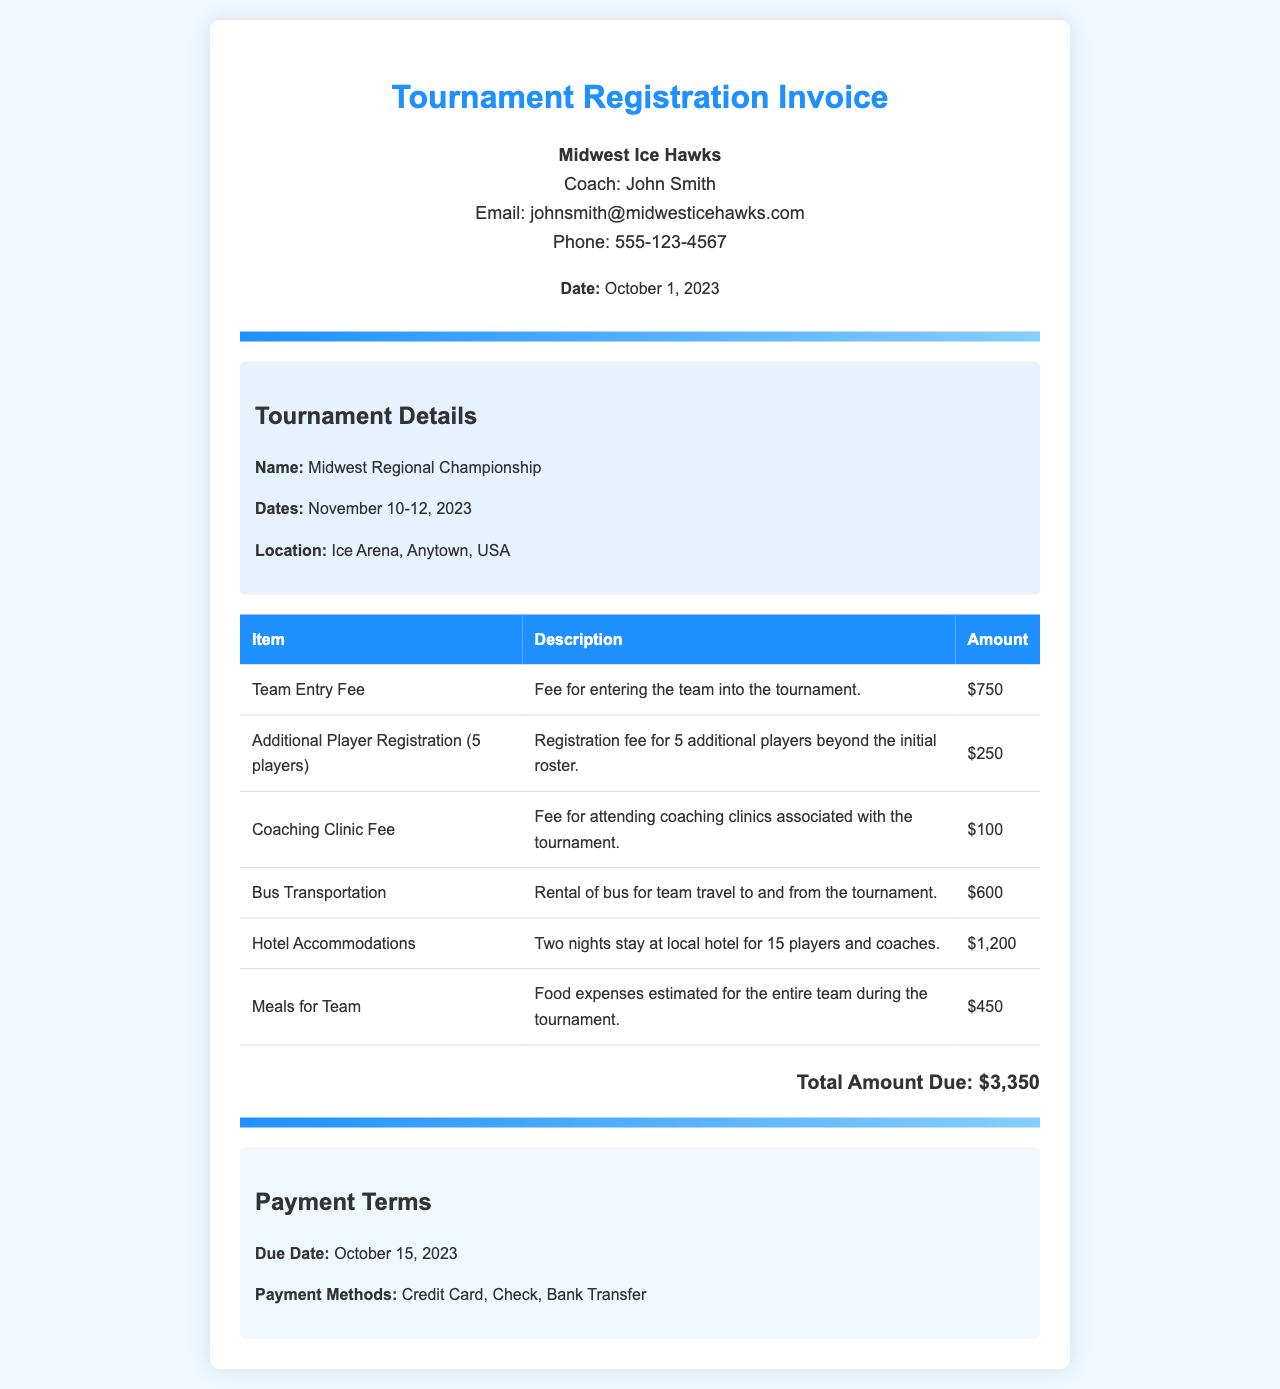What is the total amount due? The total amount due is calculated by adding all the fees listed in the invoice.
Answer: $3,350 What is the name of the tournament? The name of the tournament is listed in the details section of the document.
Answer: Midwest Regional Championship Who is the coach of the team? The coach's name is provided in the team information section of the invoice.
Answer: John Smith When is the payment due? The due date for payment is specified in the payment terms section of the document.
Answer: October 15, 2023 How much is the team entry fee? The team entry fee is shown in the table of charges in the document.
Answer: $750 What additional service incurred a fee of $100? The document lists specific services with their associated fees; this service is categorized accordingly.
Answer: Coaching Clinic Fee How many nights will the team stay at the hotel? The number of nights for hotel accommodations is mentioned in the description of that charge.
Answer: Two nights How many players' registrations are included in the additional fee? The invoice details the number of additional registrations in the related entry.
Answer: 5 players What payment methods are accepted for the invoice? The accepted payment methods are listed in the payment terms section of the document.
Answer: Credit Card, Check, Bank Transfer 